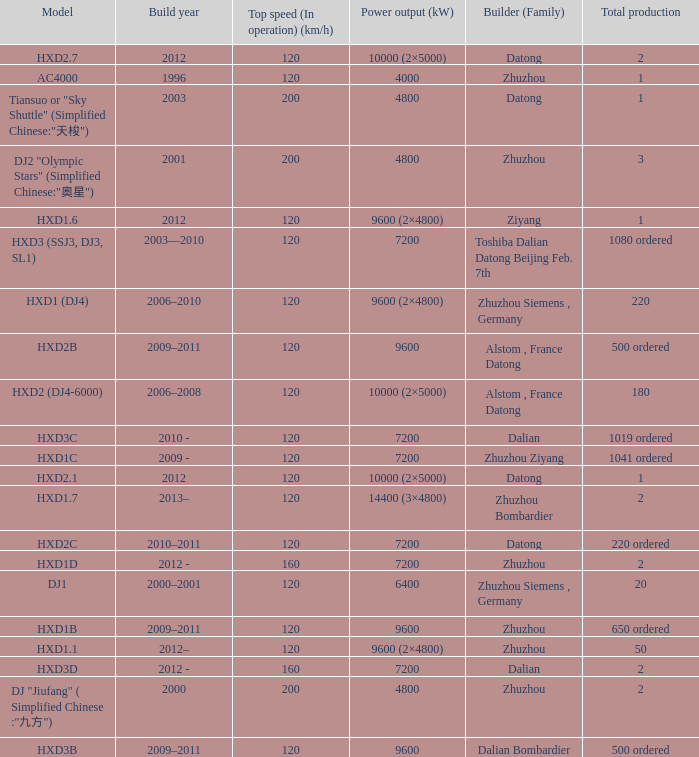What model has a builder of zhuzhou, and a power output of 9600 (kw)? HXD1B. 